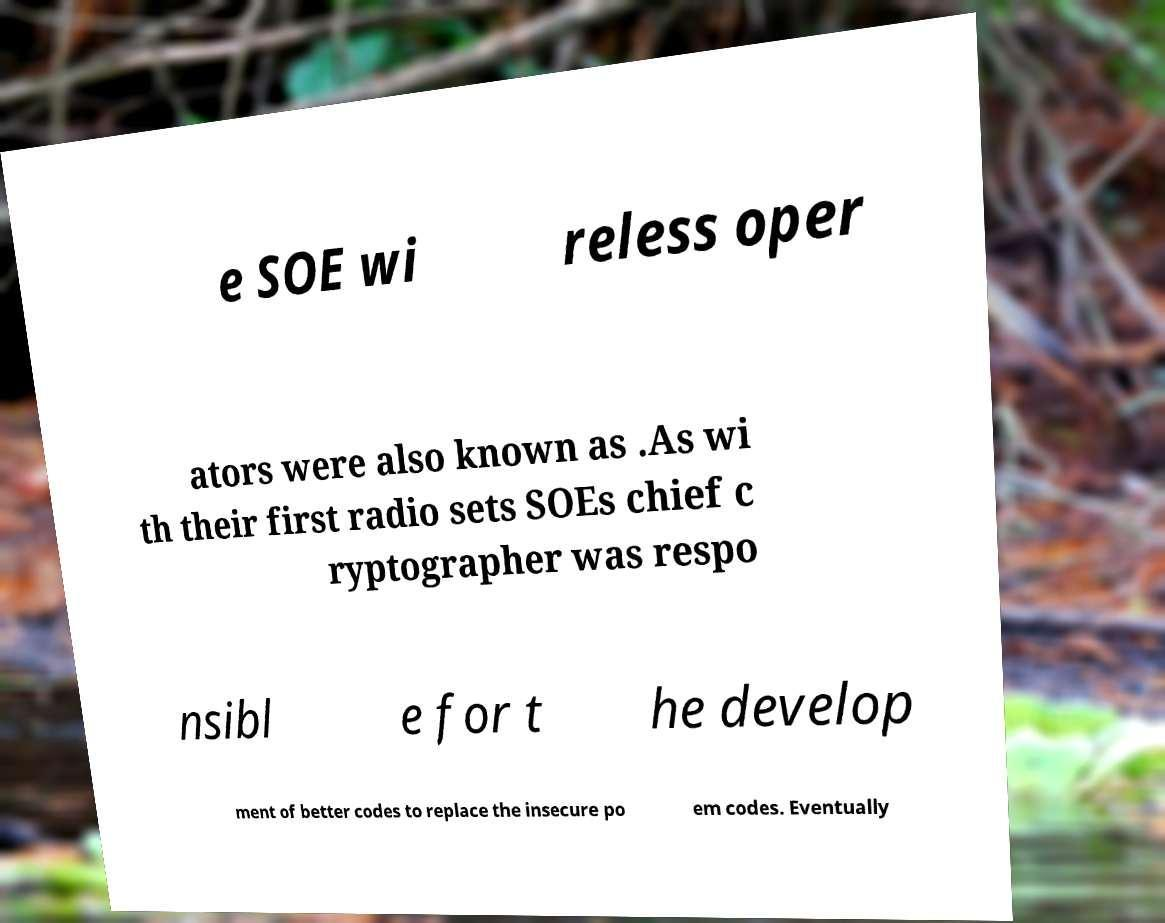There's text embedded in this image that I need extracted. Can you transcribe it verbatim? e SOE wi reless oper ators were also known as .As wi th their first radio sets SOEs chief c ryptographer was respo nsibl e for t he develop ment of better codes to replace the insecure po em codes. Eventually 